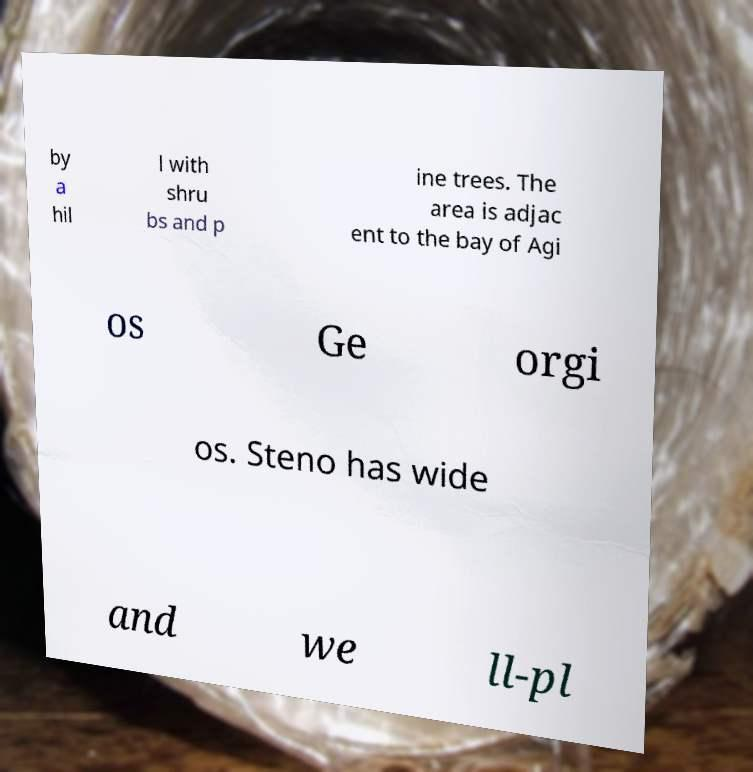Can you read and provide the text displayed in the image?This photo seems to have some interesting text. Can you extract and type it out for me? by a hil l with shru bs and p ine trees. The area is adjac ent to the bay of Agi os Ge orgi os. Steno has wide and we ll-pl 